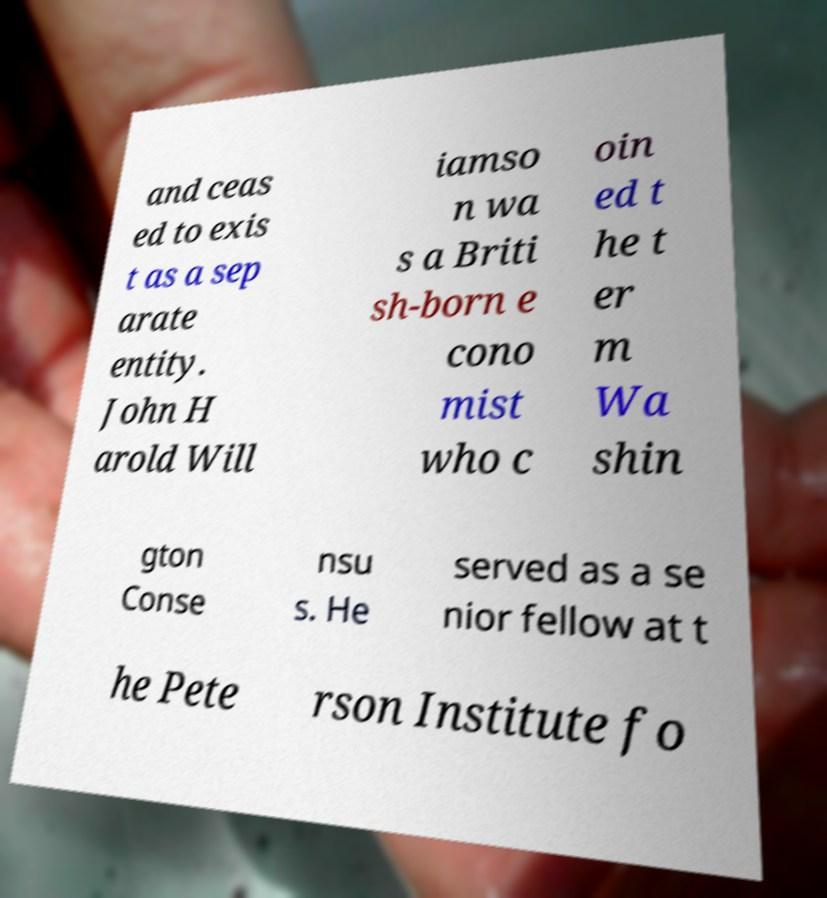Please read and relay the text visible in this image. What does it say? and ceas ed to exis t as a sep arate entity. John H arold Will iamso n wa s a Briti sh-born e cono mist who c oin ed t he t er m Wa shin gton Conse nsu s. He served as a se nior fellow at t he Pete rson Institute fo 